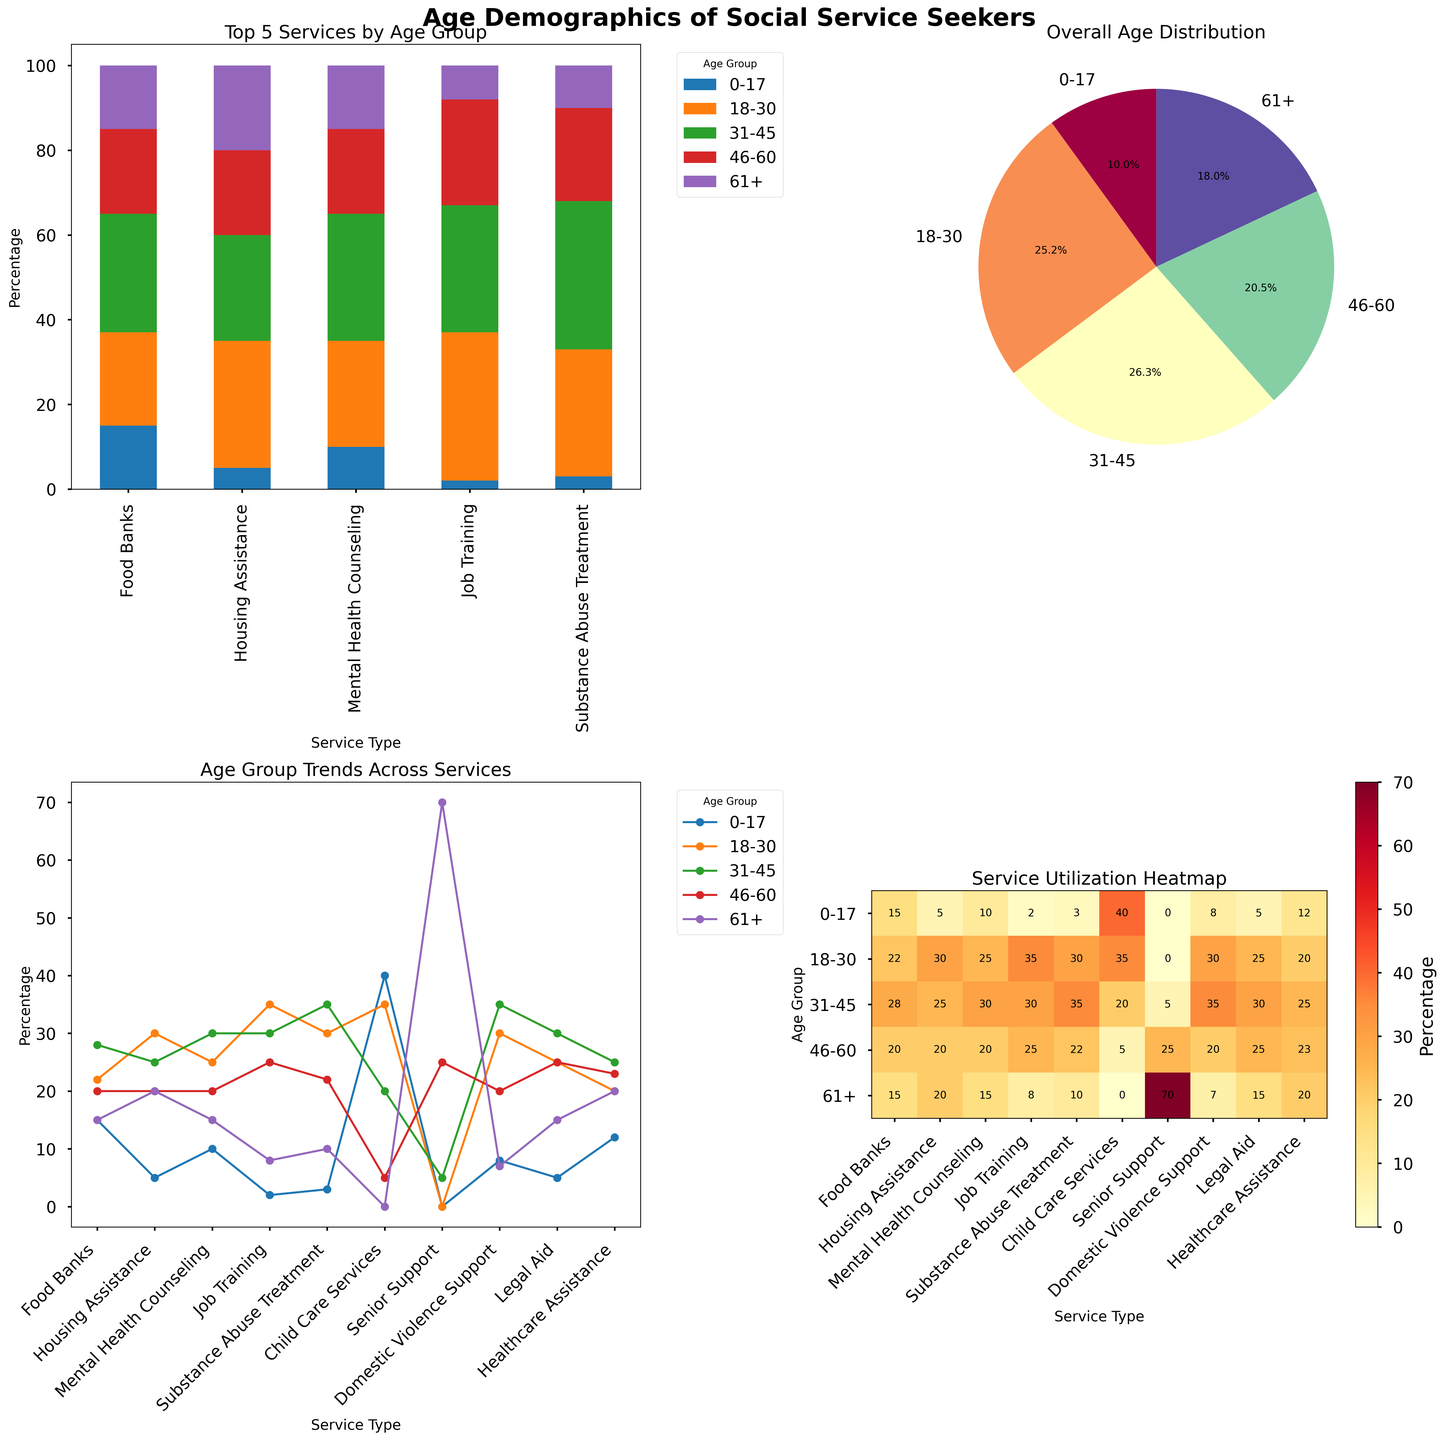How many services have age group '0-17' as the largest demographic? Observe the bar chart in the top left subplot. The tallest bar portion for '0-17' appears in 'Child Care Services' and 'Food Banks'. Count these instances.
Answer: 2 Which age group accounts for the highest percentage in the 'Senior Support' service? Look at the heights of the segments for 'Senior Support' in the bar chart. The '61+' age group has the most significant portion, verifying with the legend.
Answer: 61+ In the heatmap, which service type is utilized the most by the '18-30' age group? Find the column corresponding to '18-30' in the heatmap and observe the brightest (deepest red) cell. It corresponds to 'Job Training'.
Answer: Job Training What's the trend of '31-45' age group across all services in the line chart? Check the line representing '31-45' in the line chart's legend and follow it across the x-axis. The trend shows an upward movement and a peak around 'Substance Abuse Treatment' and then a slight decline.
Answer: Peaks at 'Substance Abuse Treatment' How does the 'Child Care Services' distribution differ between ages '0-17' and '61+'? In the bar chart for 'Child Care Services,' compare the height of the bar segments for '0-17' and '61+'. '0-17' is significantly higher, while '61+' is absent.
Answer: '0-17' is much higher In the pie chart, which age group constitutes the smallest overall portion? Check the slices in the pie chart and their labels. The '0-17' age group is the smallest slice.
Answer: 0-17 What's the most notable feature of the 'Legal Aid' service in terms of age distribution? In the bar chart, observe 'Legal Aid'. All age groups have relatively uniform heights compared to other services, indicating a balanced age distribution.
Answer: Relatively uniform distribution Which service has notably more '18-30' seekers compared to '0-17'? Compare '18-30' and '0-17' segments in the bar chart. 'Job Training' and 'Housing Assistance' stand out as having significantly taller '18-30' segments.
Answer: Job Training and Housing Assistance In the heatmap, which age group is spread most evenly across different services? Observe the heatmap's rows to see which one has the most uniform coloring. The '46-60' age group shows the most even distribution.
Answer: 46-60 What is the total percentage of '31-45' and '46-60' age groups seeking 'Mental Health Counseling'? Adding the respective segments in the bar chart for 'Mental Health Counseling' (30% for '31-45' + 20% for '46-60') gives 50%.
Answer: 50% 